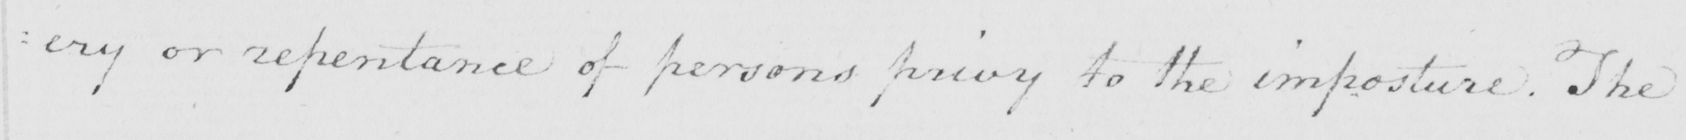What text is written in this handwritten line? : ery or repentance of persons privy to the imposture . The 